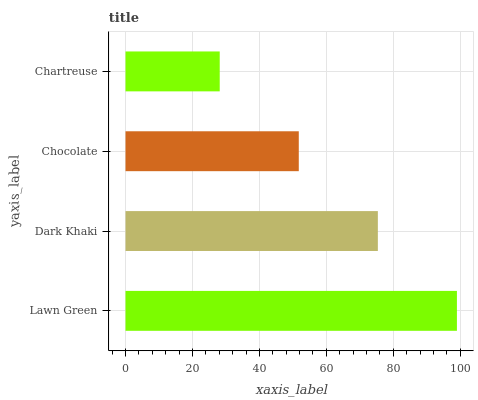Is Chartreuse the minimum?
Answer yes or no. Yes. Is Lawn Green the maximum?
Answer yes or no. Yes. Is Dark Khaki the minimum?
Answer yes or no. No. Is Dark Khaki the maximum?
Answer yes or no. No. Is Lawn Green greater than Dark Khaki?
Answer yes or no. Yes. Is Dark Khaki less than Lawn Green?
Answer yes or no. Yes. Is Dark Khaki greater than Lawn Green?
Answer yes or no. No. Is Lawn Green less than Dark Khaki?
Answer yes or no. No. Is Dark Khaki the high median?
Answer yes or no. Yes. Is Chocolate the low median?
Answer yes or no. Yes. Is Chocolate the high median?
Answer yes or no. No. Is Chartreuse the low median?
Answer yes or no. No. 